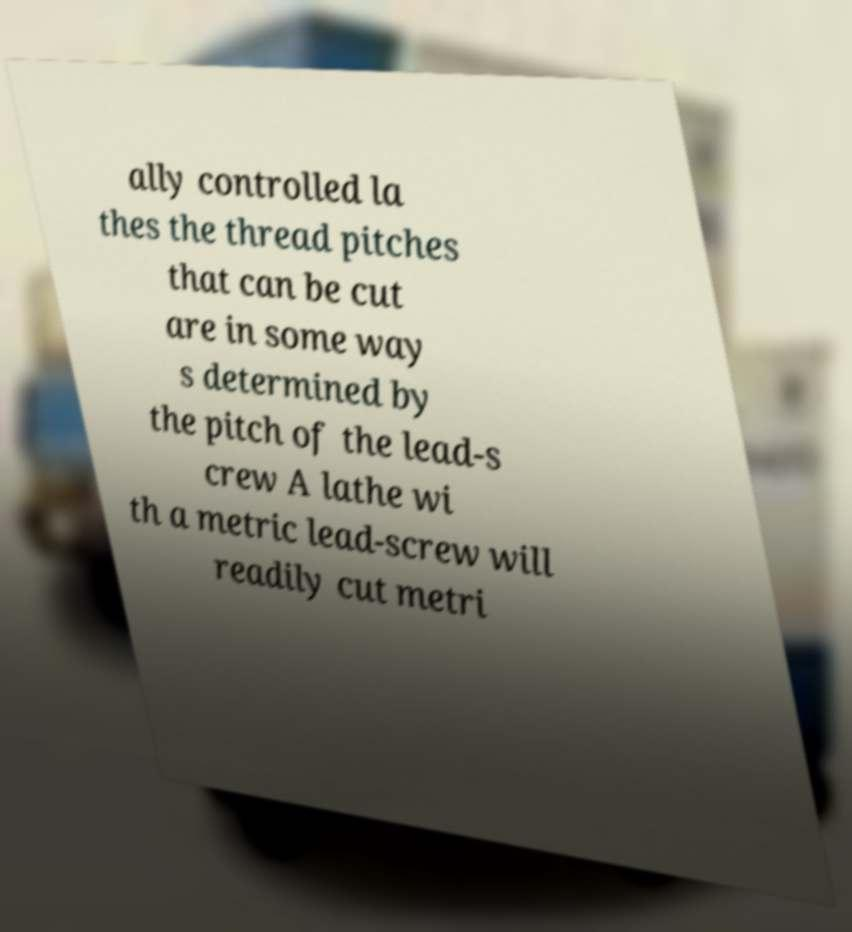Can you accurately transcribe the text from the provided image for me? ally controlled la thes the thread pitches that can be cut are in some way s determined by the pitch of the lead-s crew A lathe wi th a metric lead-screw will readily cut metri 